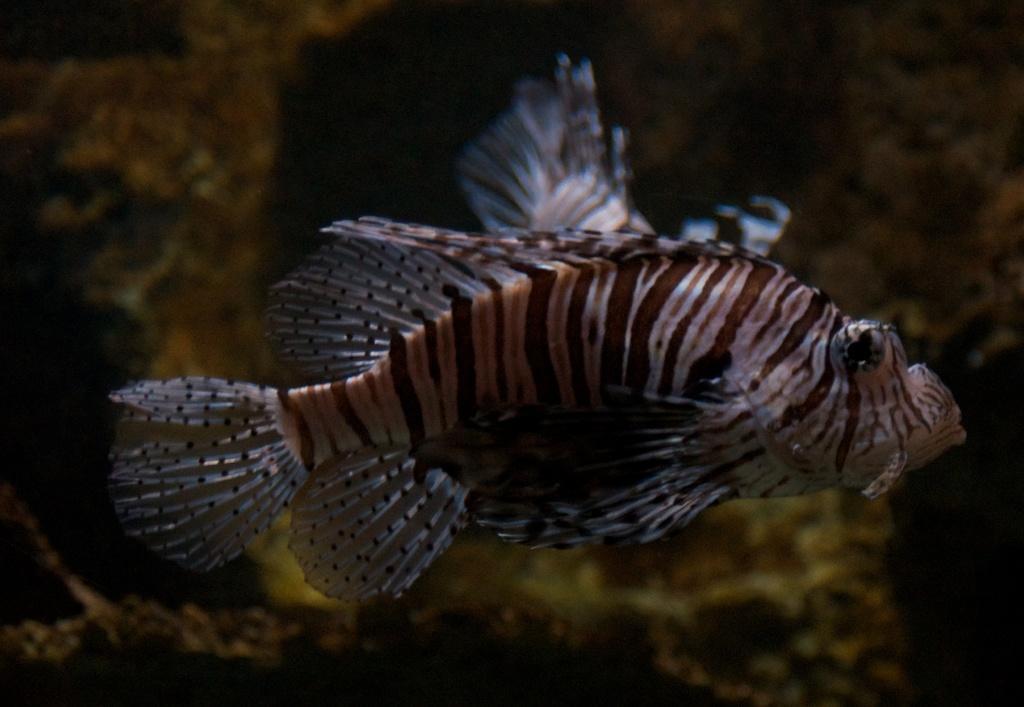In one or two sentences, can you explain what this image depicts? In this picture there is a fish in the center of the image and the background area of the image is blur. 